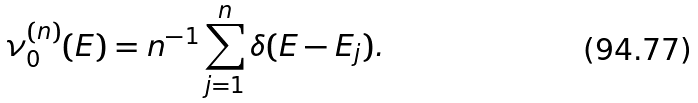<formula> <loc_0><loc_0><loc_500><loc_500>\nu _ { 0 } ^ { ( n ) } ( E ) = n ^ { - 1 } \sum _ { j = 1 } ^ { n } \delta ( E - E _ { j } ) .</formula> 